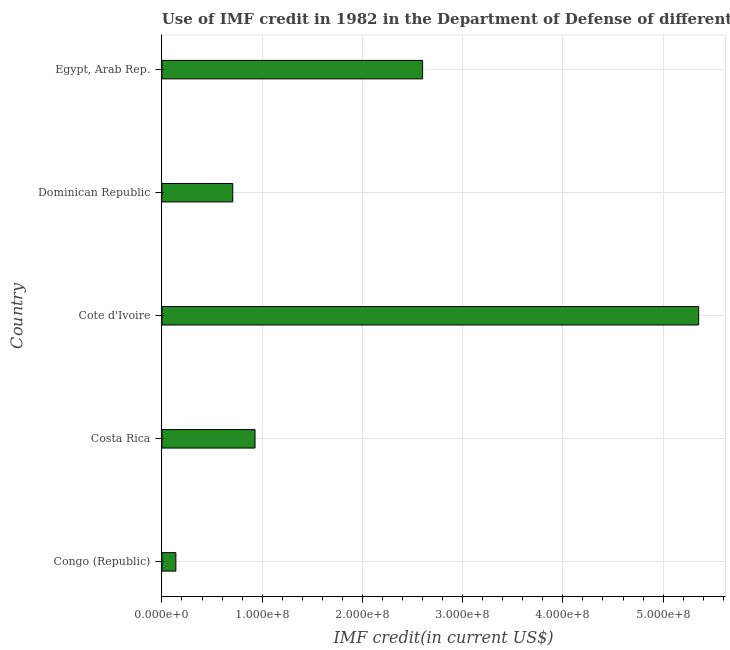Does the graph contain any zero values?
Provide a succinct answer. No. Does the graph contain grids?
Give a very brief answer. Yes. What is the title of the graph?
Your answer should be very brief. Use of IMF credit in 1982 in the Department of Defense of different countries. What is the label or title of the X-axis?
Keep it short and to the point. IMF credit(in current US$). What is the use of imf credit in dod in Cote d'Ivoire?
Your answer should be very brief. 5.35e+08. Across all countries, what is the maximum use of imf credit in dod?
Give a very brief answer. 5.35e+08. Across all countries, what is the minimum use of imf credit in dod?
Give a very brief answer. 1.39e+07. In which country was the use of imf credit in dod maximum?
Provide a succinct answer. Cote d'Ivoire. In which country was the use of imf credit in dod minimum?
Offer a terse response. Congo (Republic). What is the sum of the use of imf credit in dod?
Provide a succinct answer. 9.73e+08. What is the difference between the use of imf credit in dod in Congo (Republic) and Cote d'Ivoire?
Your answer should be compact. -5.22e+08. What is the average use of imf credit in dod per country?
Give a very brief answer. 1.95e+08. What is the median use of imf credit in dod?
Offer a very short reply. 9.29e+07. In how many countries, is the use of imf credit in dod greater than 60000000 US$?
Your answer should be very brief. 4. What is the ratio of the use of imf credit in dod in Congo (Republic) to that in Egypt, Arab Rep.?
Provide a short and direct response. 0.05. Is the use of imf credit in dod in Costa Rica less than that in Dominican Republic?
Your answer should be compact. No. What is the difference between the highest and the second highest use of imf credit in dod?
Your response must be concise. 2.75e+08. Is the sum of the use of imf credit in dod in Congo (Republic) and Egypt, Arab Rep. greater than the maximum use of imf credit in dod across all countries?
Provide a short and direct response. No. What is the difference between the highest and the lowest use of imf credit in dod?
Your answer should be very brief. 5.22e+08. What is the IMF credit(in current US$) of Congo (Republic)?
Offer a very short reply. 1.39e+07. What is the IMF credit(in current US$) in Costa Rica?
Ensure brevity in your answer.  9.29e+07. What is the IMF credit(in current US$) of Cote d'Ivoire?
Make the answer very short. 5.35e+08. What is the IMF credit(in current US$) of Dominican Republic?
Make the answer very short. 7.07e+07. What is the IMF credit(in current US$) in Egypt, Arab Rep.?
Offer a very short reply. 2.60e+08. What is the difference between the IMF credit(in current US$) in Congo (Republic) and Costa Rica?
Offer a very short reply. -7.90e+07. What is the difference between the IMF credit(in current US$) in Congo (Republic) and Cote d'Ivoire?
Give a very brief answer. -5.22e+08. What is the difference between the IMF credit(in current US$) in Congo (Republic) and Dominican Republic?
Your answer should be compact. -5.68e+07. What is the difference between the IMF credit(in current US$) in Congo (Republic) and Egypt, Arab Rep.?
Offer a very short reply. -2.46e+08. What is the difference between the IMF credit(in current US$) in Costa Rica and Cote d'Ivoire?
Provide a succinct answer. -4.43e+08. What is the difference between the IMF credit(in current US$) in Costa Rica and Dominican Republic?
Provide a short and direct response. 2.22e+07. What is the difference between the IMF credit(in current US$) in Costa Rica and Egypt, Arab Rep.?
Make the answer very short. -1.67e+08. What is the difference between the IMF credit(in current US$) in Cote d'Ivoire and Dominican Republic?
Keep it short and to the point. 4.65e+08. What is the difference between the IMF credit(in current US$) in Cote d'Ivoire and Egypt, Arab Rep.?
Your answer should be very brief. 2.75e+08. What is the difference between the IMF credit(in current US$) in Dominican Republic and Egypt, Arab Rep.?
Your answer should be very brief. -1.89e+08. What is the ratio of the IMF credit(in current US$) in Congo (Republic) to that in Costa Rica?
Your response must be concise. 0.15. What is the ratio of the IMF credit(in current US$) in Congo (Republic) to that in Cote d'Ivoire?
Give a very brief answer. 0.03. What is the ratio of the IMF credit(in current US$) in Congo (Republic) to that in Dominican Republic?
Offer a very short reply. 0.2. What is the ratio of the IMF credit(in current US$) in Congo (Republic) to that in Egypt, Arab Rep.?
Keep it short and to the point. 0.05. What is the ratio of the IMF credit(in current US$) in Costa Rica to that in Cote d'Ivoire?
Your answer should be compact. 0.17. What is the ratio of the IMF credit(in current US$) in Costa Rica to that in Dominican Republic?
Give a very brief answer. 1.31. What is the ratio of the IMF credit(in current US$) in Costa Rica to that in Egypt, Arab Rep.?
Offer a terse response. 0.36. What is the ratio of the IMF credit(in current US$) in Cote d'Ivoire to that in Dominican Republic?
Your answer should be very brief. 7.57. What is the ratio of the IMF credit(in current US$) in Cote d'Ivoire to that in Egypt, Arab Rep.?
Provide a succinct answer. 2.06. What is the ratio of the IMF credit(in current US$) in Dominican Republic to that in Egypt, Arab Rep.?
Your answer should be compact. 0.27. 